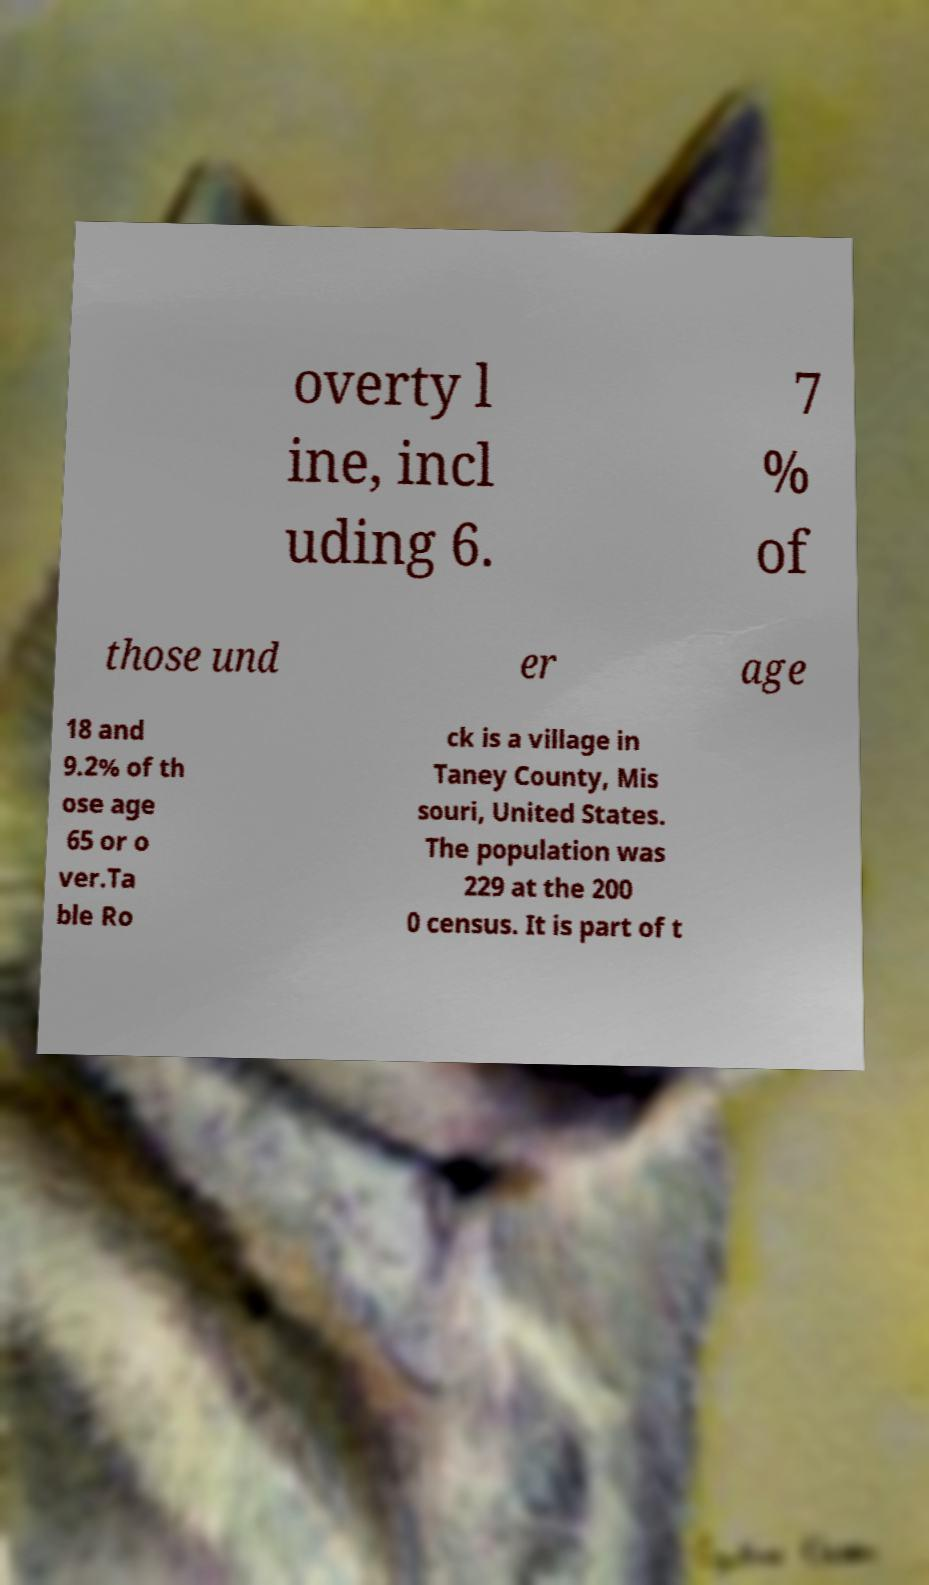Could you extract and type out the text from this image? overty l ine, incl uding 6. 7 % of those und er age 18 and 9.2% of th ose age 65 or o ver.Ta ble Ro ck is a village in Taney County, Mis souri, United States. The population was 229 at the 200 0 census. It is part of t 